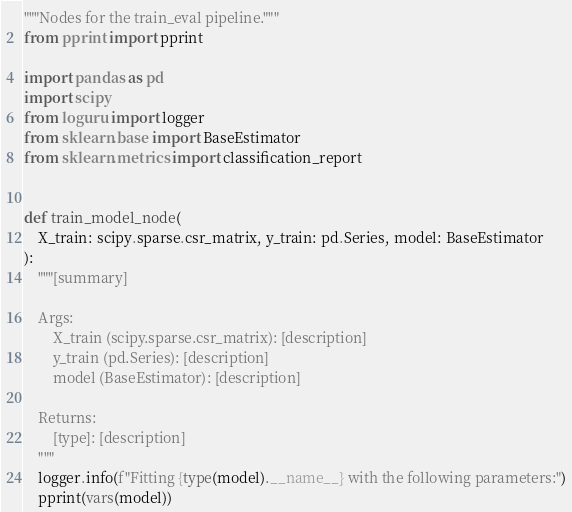Convert code to text. <code><loc_0><loc_0><loc_500><loc_500><_Python_>"""Nodes for the train_eval pipeline."""
from pprint import pprint

import pandas as pd
import scipy
from loguru import logger
from sklearn.base import BaseEstimator
from sklearn.metrics import classification_report


def train_model_node(
    X_train: scipy.sparse.csr_matrix, y_train: pd.Series, model: BaseEstimator
):
    """[summary]

    Args:
        X_train (scipy.sparse.csr_matrix): [description]
        y_train (pd.Series): [description]
        model (BaseEstimator): [description]

    Returns:
        [type]: [description]
    """
    logger.info(f"Fitting {type(model).__name__} with the following parameters:")
    pprint(vars(model))</code> 